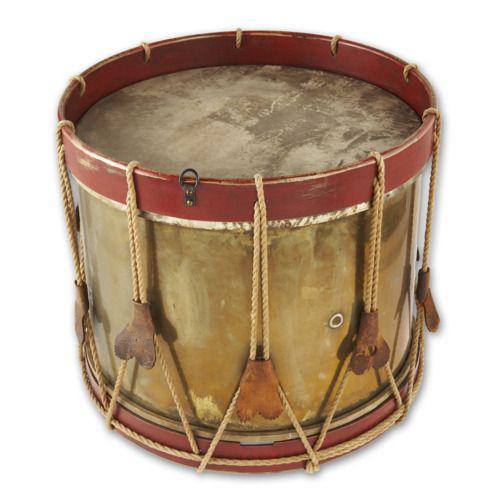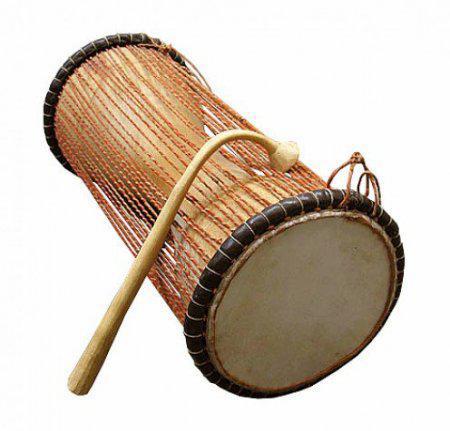The first image is the image on the left, the second image is the image on the right. Assess this claim about the two images: "The left image contains a neat row of three brown drums, and the right image features a single upright brown drum.". Correct or not? Answer yes or no. No. The first image is the image on the left, the second image is the image on the right. Assess this claim about the two images: "One image shows a set of three congas and the other shows a single conga drum.". Correct or not? Answer yes or no. No. 